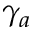Convert formula to latex. <formula><loc_0><loc_0><loc_500><loc_500>\gamma _ { a }</formula> 